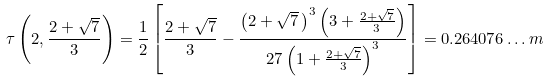Convert formula to latex. <formula><loc_0><loc_0><loc_500><loc_500>\tau \left ( 2 , \frac { 2 + \sqrt { 7 } } 3 \right ) = \frac { 1 } { 2 } \left [ \frac { 2 + \sqrt { 7 } } 3 - \frac { \left ( 2 + \sqrt { 7 } \, \right ) ^ { 3 } \left ( 3 + \frac { 2 + \sqrt { 7 } } 3 \right ) } { 2 7 \left ( 1 + \frac { 2 + \sqrt { 7 } } 3 \right ) ^ { 3 } } \right ] = 0 . 2 6 4 0 7 6 \dots m</formula> 